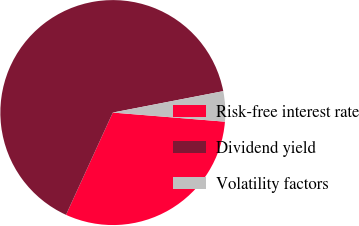<chart> <loc_0><loc_0><loc_500><loc_500><pie_chart><fcel>Risk-free interest rate<fcel>Dividend yield<fcel>Volatility factors<nl><fcel>30.54%<fcel>65.12%<fcel>4.34%<nl></chart> 